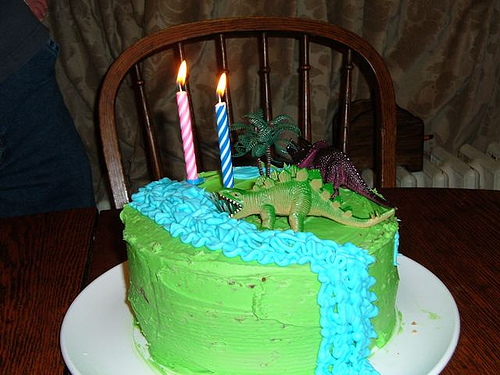<image>
Is the dinosaur in front of the candle? Yes. The dinosaur is positioned in front of the candle, appearing closer to the camera viewpoint. 